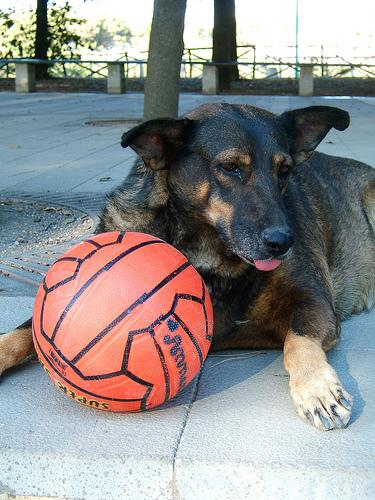Describe the state and color of the dog's tongue. The dog's tongue is pink and it is sticking out. Give a brief description of the environment and other objects in the background of the image. There are green benches for sitting, a tree trunk, and short stone pillars in the background, with sunlight casting shadows on the concrete sidewalk. What is the color of the dog's eyes and what condition do they seem to be in? The dog's eyes are brown and they appear to be open but seem like they need to be cleaned. What type of surface are the dog, ball, and other objects positioned on? They are positioned on a concrete ground, featuring a white section and a crack. Mention any unique features or characteristics of the dog's paw and nails. The dog's paw, which is a front paw, has grey-colored nails, and it is lying on the ground. Provide a brief description of the dog's physical appearance and position. The dog is a dark brownish, brindle-colored dog lying on the sidewalk with its tongue sticking out. What elements of the image could be related to a complex reasoning task? Interactions between the dog and the ball, the dog's emotions based on its facial expressions, and the effect of sunlight on the visible shadows could be related to complex reasoning tasks. Identify the main object beside the dog and provide its color and any distinctive features. An orange ball with black lines and blue writing, which appears to be a basketball, is located near the dog. Count the total number of visible objects in the image, including the dog and background elements. There are at least 13 visible objects, including the dog, ball, tree trunk, benches, stone pillars, drain cover, and shadow on the sidewalk. State the condition of the dog's eyes. The eyes are open and brown but need to be cleaned Is that a large ice cream cone melting on the sidewalk near the crack in the concrete? This interrogative sentence refers to a nonexistent object (an ice cream cone) related to the existing crack in the sidewalk. It would lead the viewer to look for an imaginary detail and make them question the image content. Discuss the background scene in the image. A tree trunk, short stone pillars, and green concrete benches in the background on the sidewalk What material is the surface the dog is lying on? Concrete Mention a notable feature about the ball in the image. The ball has black lines and letters on it Provide a description of the dog's ears in the image. Wagging ears Give a brief description of the dog and the ball in the image. A brownish dog with its tongue out lies next to an orange ball with black lines on it What is the color of the ball's writing? Blue Find the little yellow bird perched on the tree trunk, it's so adorable! No, it's not mentioned in the image. What is the position of the dog's paw in the image? Front paw What type of tree is present in the background? Unable to determine tree type; only the trunk is visible Mention an object in the background and its position relative to the dog. A tree trunk is behind the dog Describe the state of the dog in the image. Lying down with tongue sticking out What color is the ball in the image? Orange What color are the dog's nails? Grey Describe the benches in the background of the image. Green concrete benches Identify the primary subject of the image. A dog lying down next to a ball Describe the position of the dog with respect to the ball. The dog is lying down next to the ball Select the correct description of the dog's tongue in the image: a) red, b) pink, c) brown, d) blue b) pink List some elements that can be observed on the sidewalk in the image. Cracks, drain cover with dirt, and sun casting shadows 